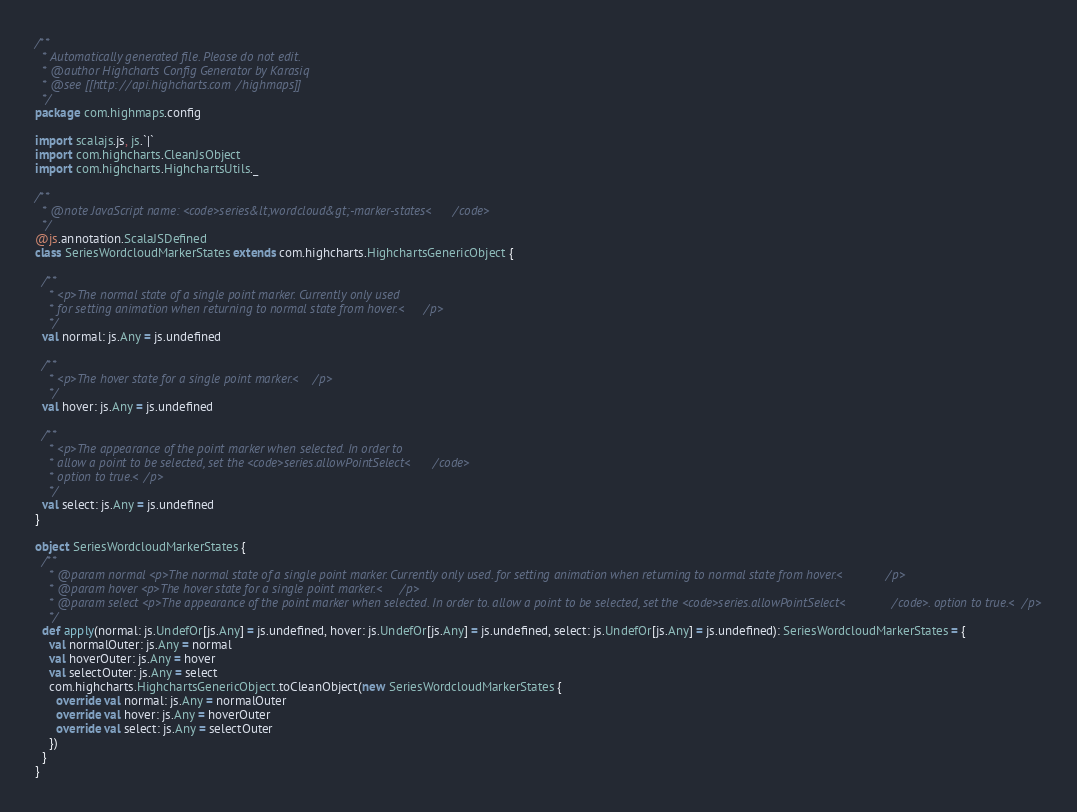Convert code to text. <code><loc_0><loc_0><loc_500><loc_500><_Scala_>/**
  * Automatically generated file. Please do not edit.
  * @author Highcharts Config Generator by Karasiq
  * @see [[http://api.highcharts.com/highmaps]]
  */
package com.highmaps.config

import scalajs.js, js.`|`
import com.highcharts.CleanJsObject
import com.highcharts.HighchartsUtils._

/**
  * @note JavaScript name: <code>series&lt;wordcloud&gt;-marker-states</code>
  */
@js.annotation.ScalaJSDefined
class SeriesWordcloudMarkerStates extends com.highcharts.HighchartsGenericObject {

  /**
    * <p>The normal state of a single point marker. Currently only used
    * for setting animation when returning to normal state from hover.</p>
    */
  val normal: js.Any = js.undefined

  /**
    * <p>The hover state for a single point marker.</p>
    */
  val hover: js.Any = js.undefined

  /**
    * <p>The appearance of the point marker when selected. In order to
    * allow a point to be selected, set the <code>series.allowPointSelect</code>
    * option to true.</p>
    */
  val select: js.Any = js.undefined
}

object SeriesWordcloudMarkerStates {
  /**
    * @param normal <p>The normal state of a single point marker. Currently only used. for setting animation when returning to normal state from hover.</p>
    * @param hover <p>The hover state for a single point marker.</p>
    * @param select <p>The appearance of the point marker when selected. In order to. allow a point to be selected, set the <code>series.allowPointSelect</code>. option to true.</p>
    */
  def apply(normal: js.UndefOr[js.Any] = js.undefined, hover: js.UndefOr[js.Any] = js.undefined, select: js.UndefOr[js.Any] = js.undefined): SeriesWordcloudMarkerStates = {
    val normalOuter: js.Any = normal
    val hoverOuter: js.Any = hover
    val selectOuter: js.Any = select
    com.highcharts.HighchartsGenericObject.toCleanObject(new SeriesWordcloudMarkerStates {
      override val normal: js.Any = normalOuter
      override val hover: js.Any = hoverOuter
      override val select: js.Any = selectOuter
    })
  }
}
</code> 